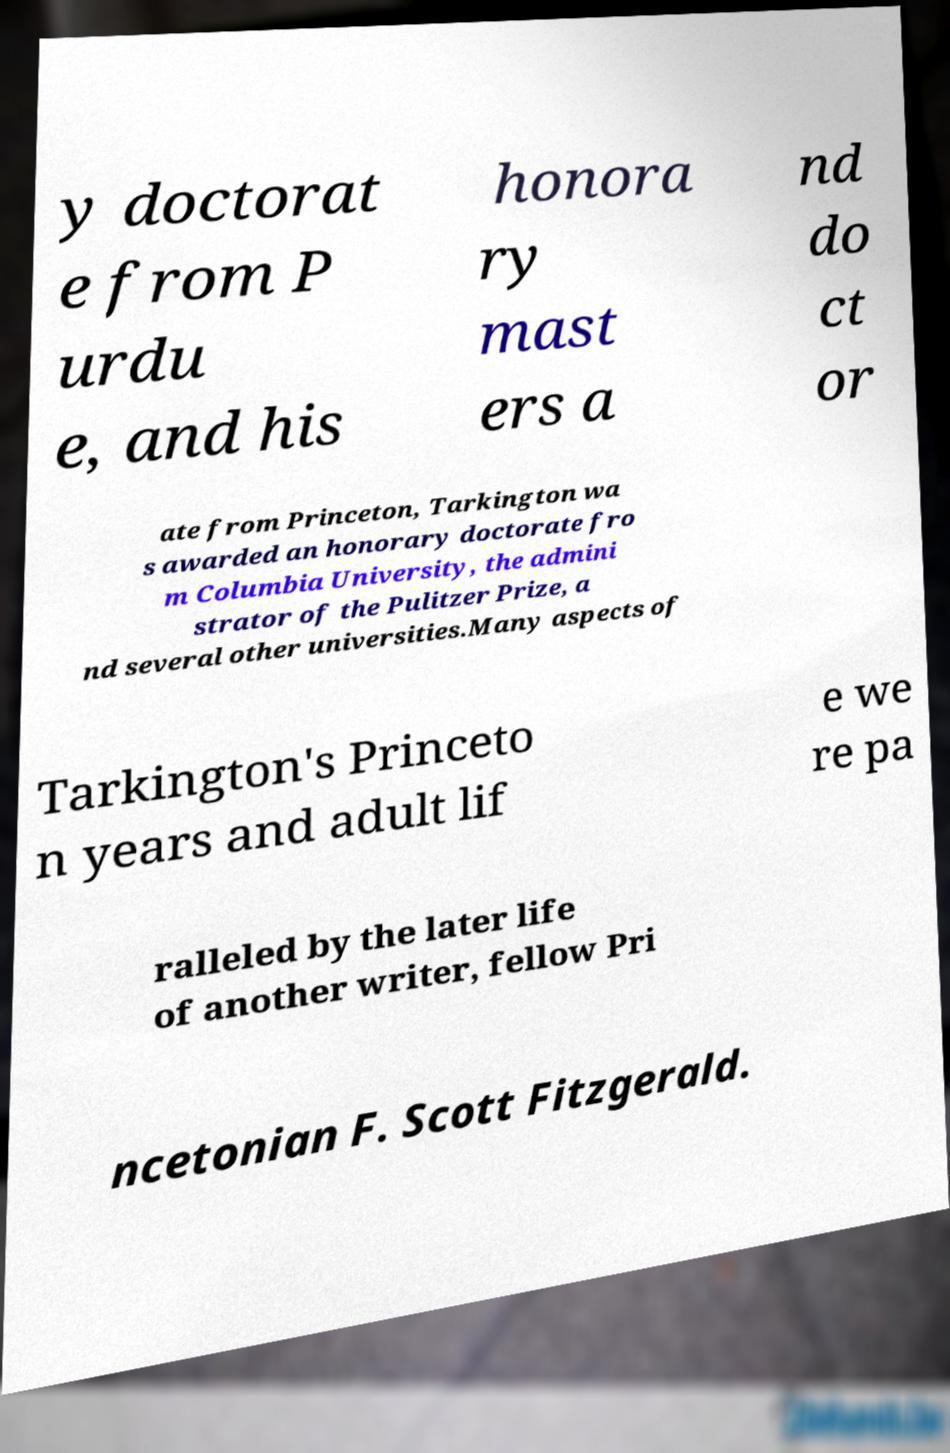For documentation purposes, I need the text within this image transcribed. Could you provide that? y doctorat e from P urdu e, and his honora ry mast ers a nd do ct or ate from Princeton, Tarkington wa s awarded an honorary doctorate fro m Columbia University, the admini strator of the Pulitzer Prize, a nd several other universities.Many aspects of Tarkington's Princeto n years and adult lif e we re pa ralleled by the later life of another writer, fellow Pri ncetonian F. Scott Fitzgerald. 